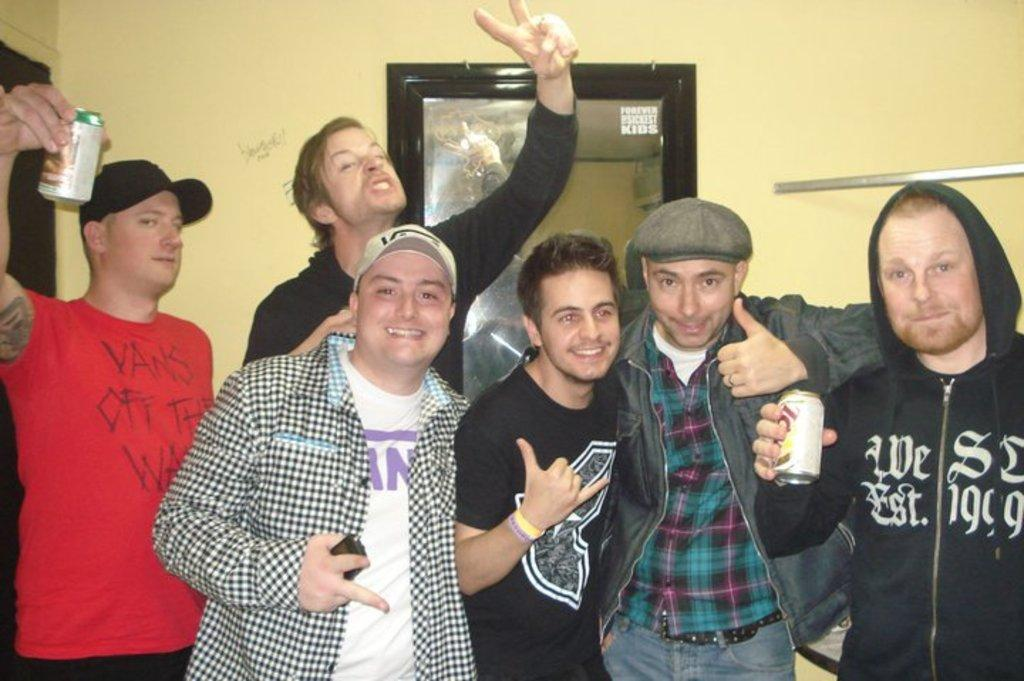<image>
Present a compact description of the photo's key features. the word off is on a red shirt with a group posing with each other 